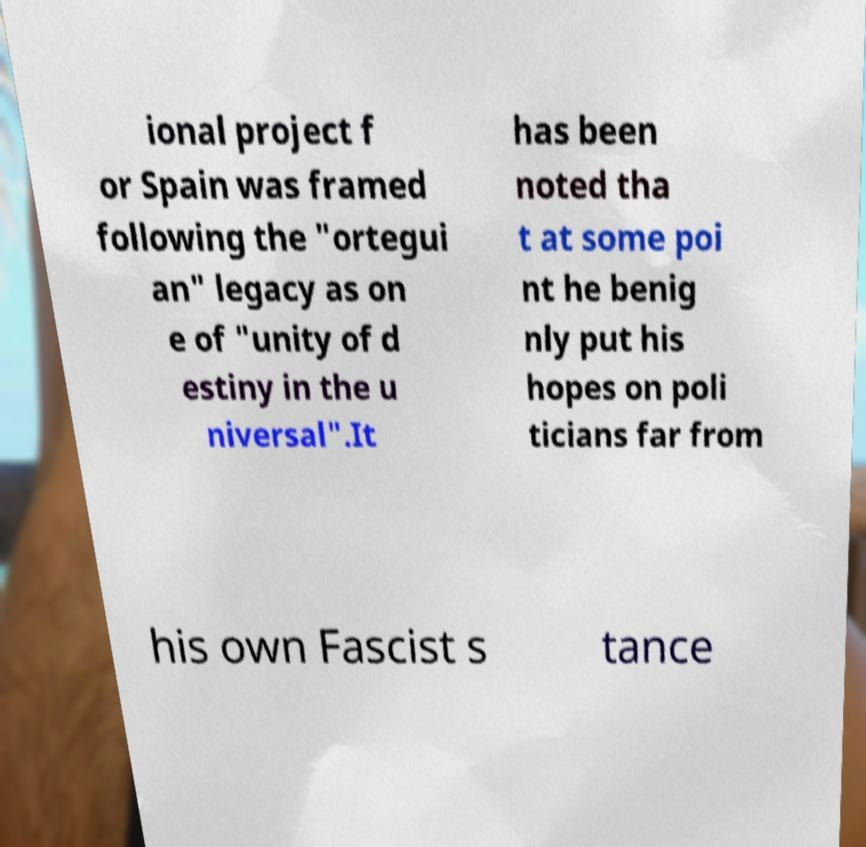I need the written content from this picture converted into text. Can you do that? ional project f or Spain was framed following the "ortegui an" legacy as on e of "unity of d estiny in the u niversal".It has been noted tha t at some poi nt he benig nly put his hopes on poli ticians far from his own Fascist s tance 